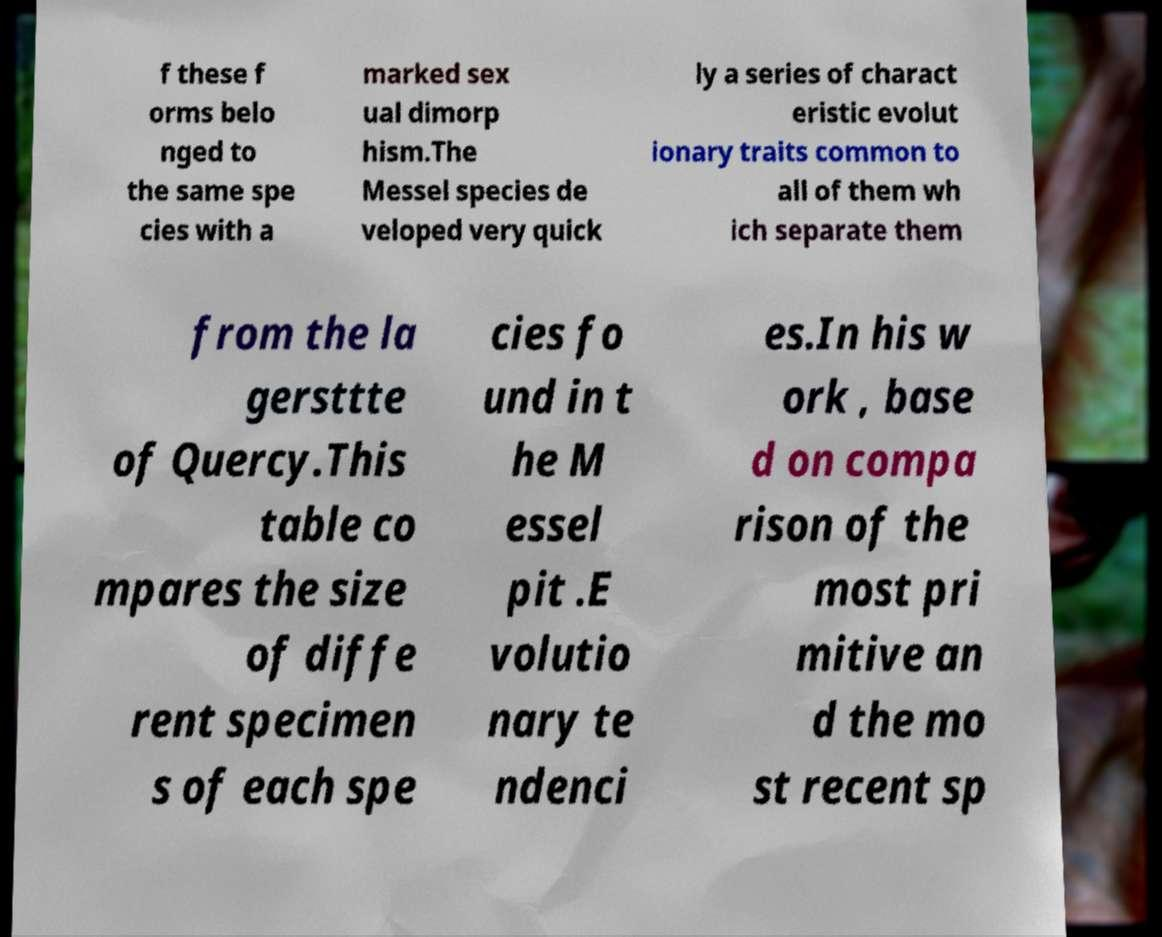Can you read and provide the text displayed in the image?This photo seems to have some interesting text. Can you extract and type it out for me? f these f orms belo nged to the same spe cies with a marked sex ual dimorp hism.The Messel species de veloped very quick ly a series of charact eristic evolut ionary traits common to all of them wh ich separate them from the la gersttte of Quercy.This table co mpares the size of diffe rent specimen s of each spe cies fo und in t he M essel pit .E volutio nary te ndenci es.In his w ork , base d on compa rison of the most pri mitive an d the mo st recent sp 